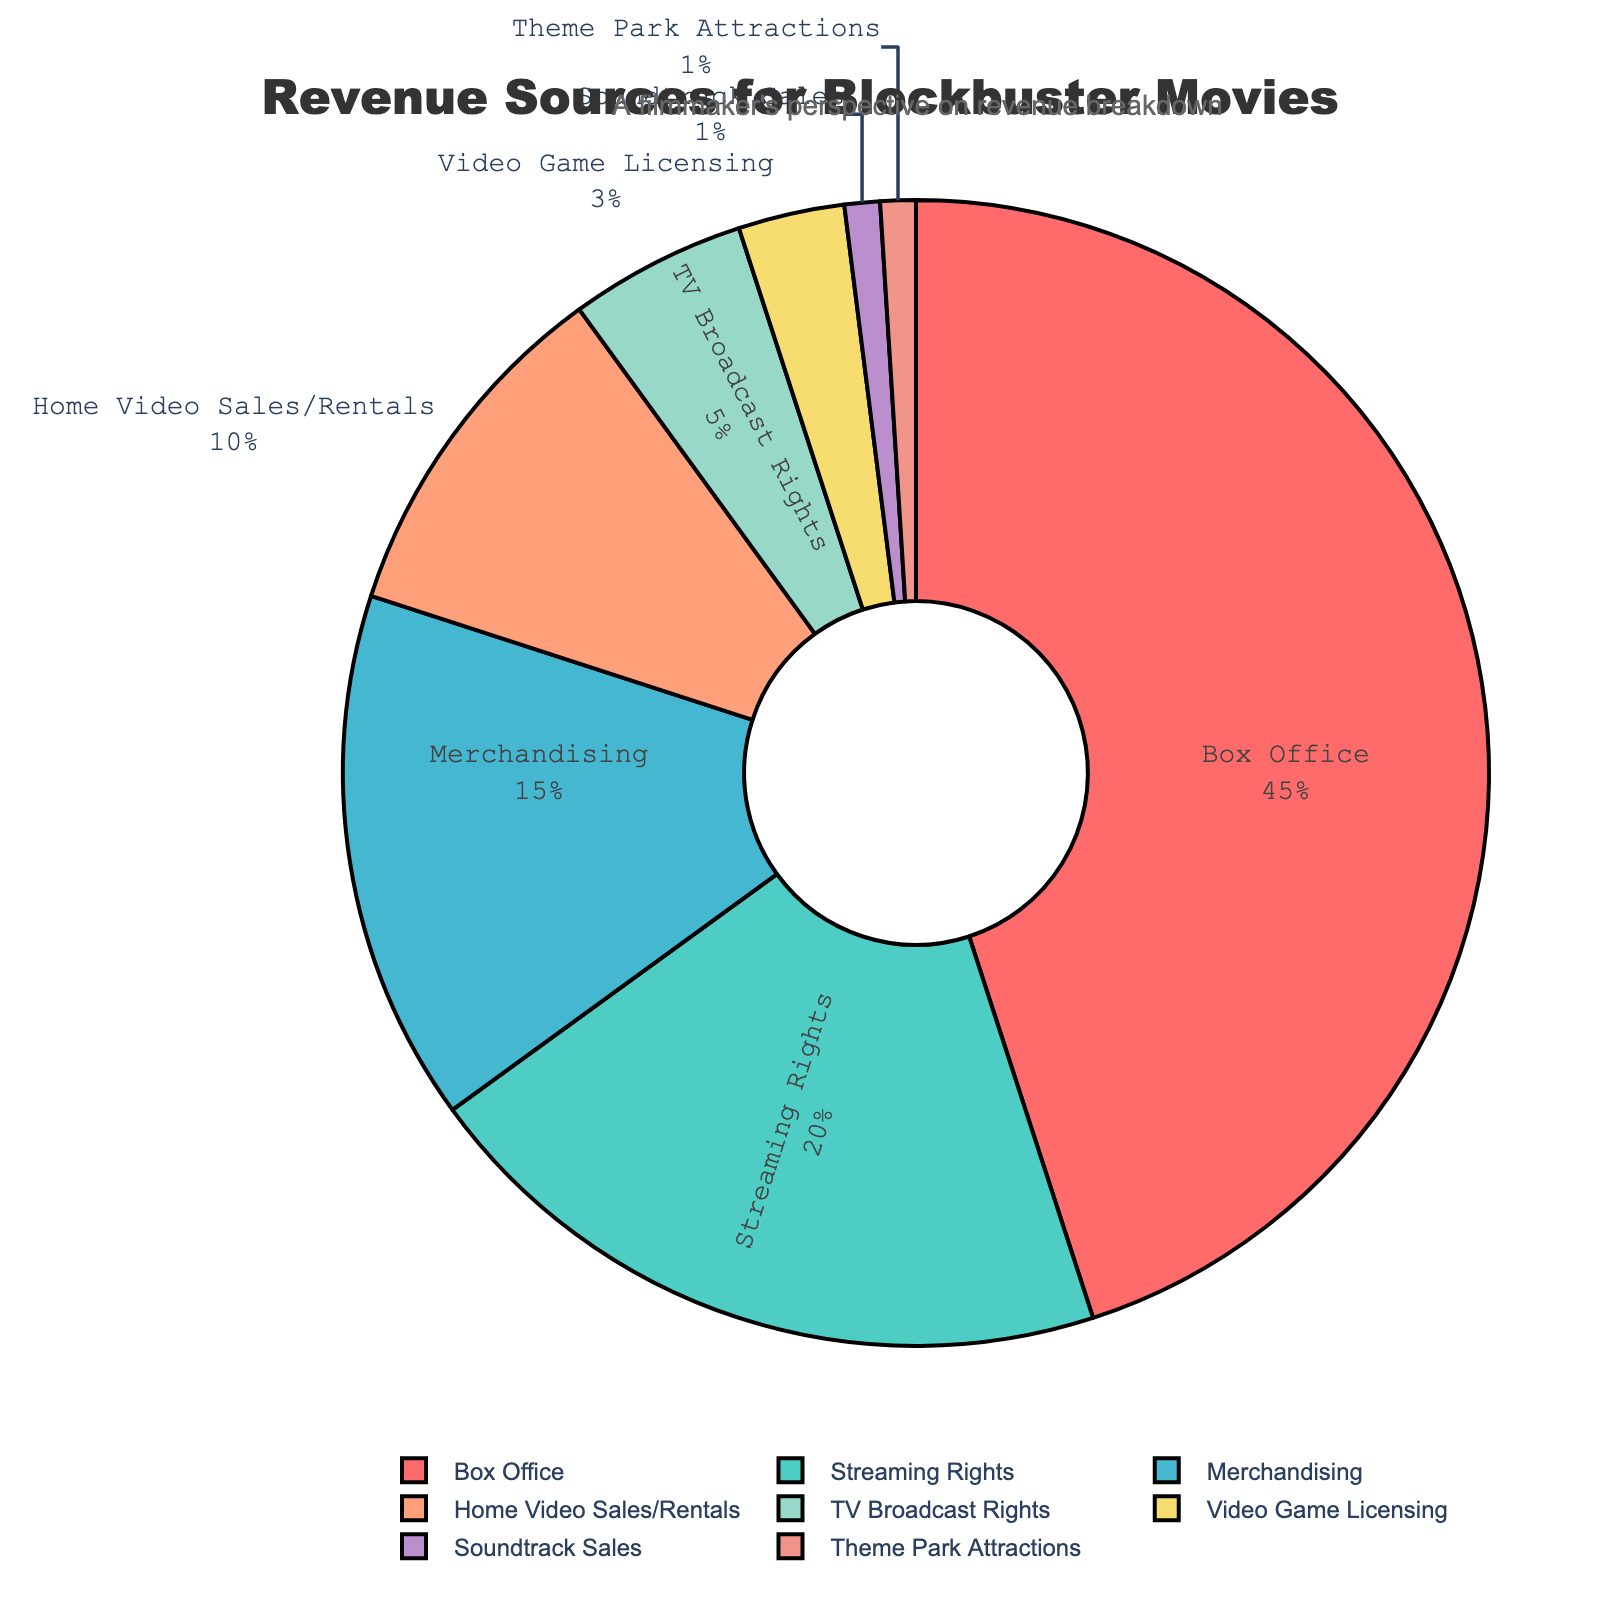What percentage of the revenue comes from Merchandising? Look at the sector labeled "Merchandising" in the pie chart. The percentage is displayed directly on the chart.
Answer: 15% Which revenue source contributes the least to the total revenue? Identify the sector with the smallest percentage in the pie chart. This is the sector labeled "Soundtrack Sales" and "Theme Park Attractions," both showing the least percentage.
Answer: Soundtrack Sales and Theme Park Attractions By how much is Box Office revenue greater than Streaming Rights revenue? Look at the percentages for both "Box Office" and "Streaming Rights". Box Office is 45%, and Streaming Rights is 20%. Subtract the percentage of Streaming Rights from the percentage of Box Office.
Answer: 25% What is the combined percentage of revenue from Home Video Sales/Rentals, TV Broadcast Rights, and Video Game Licensing? Add the percentages for Home Video Sales/Rentals (10%), TV Broadcast Rights (5%), and Video Game Licensing (3%). Calculate the sum: 10% + 5% + 3%.
Answer: 18% Which revenue source contributes more, Soundtrack Sales or Theme Park Attractions? Compare the percentages for "Soundtrack Sales" and "Theme Park Attractions". Both are labeled as contributing 1%.
Answer: They contribute equally What are the three largest revenue sources? Identify the three sectors in the pie chart with the largest percentages. These are "Box Office" (45%), "Streaming Rights" (20%), and "Merchandising" (15%).
Answer: Box Office, Streaming Rights, Merchandising What percentage of the total revenue comes from sources other than the Box Office? Subtract the percentage of Box Office revenue (45%) from the total (100%) to find the cumulative percentage of all other sources. 100% - 45% = 55%.
Answer: 55% 